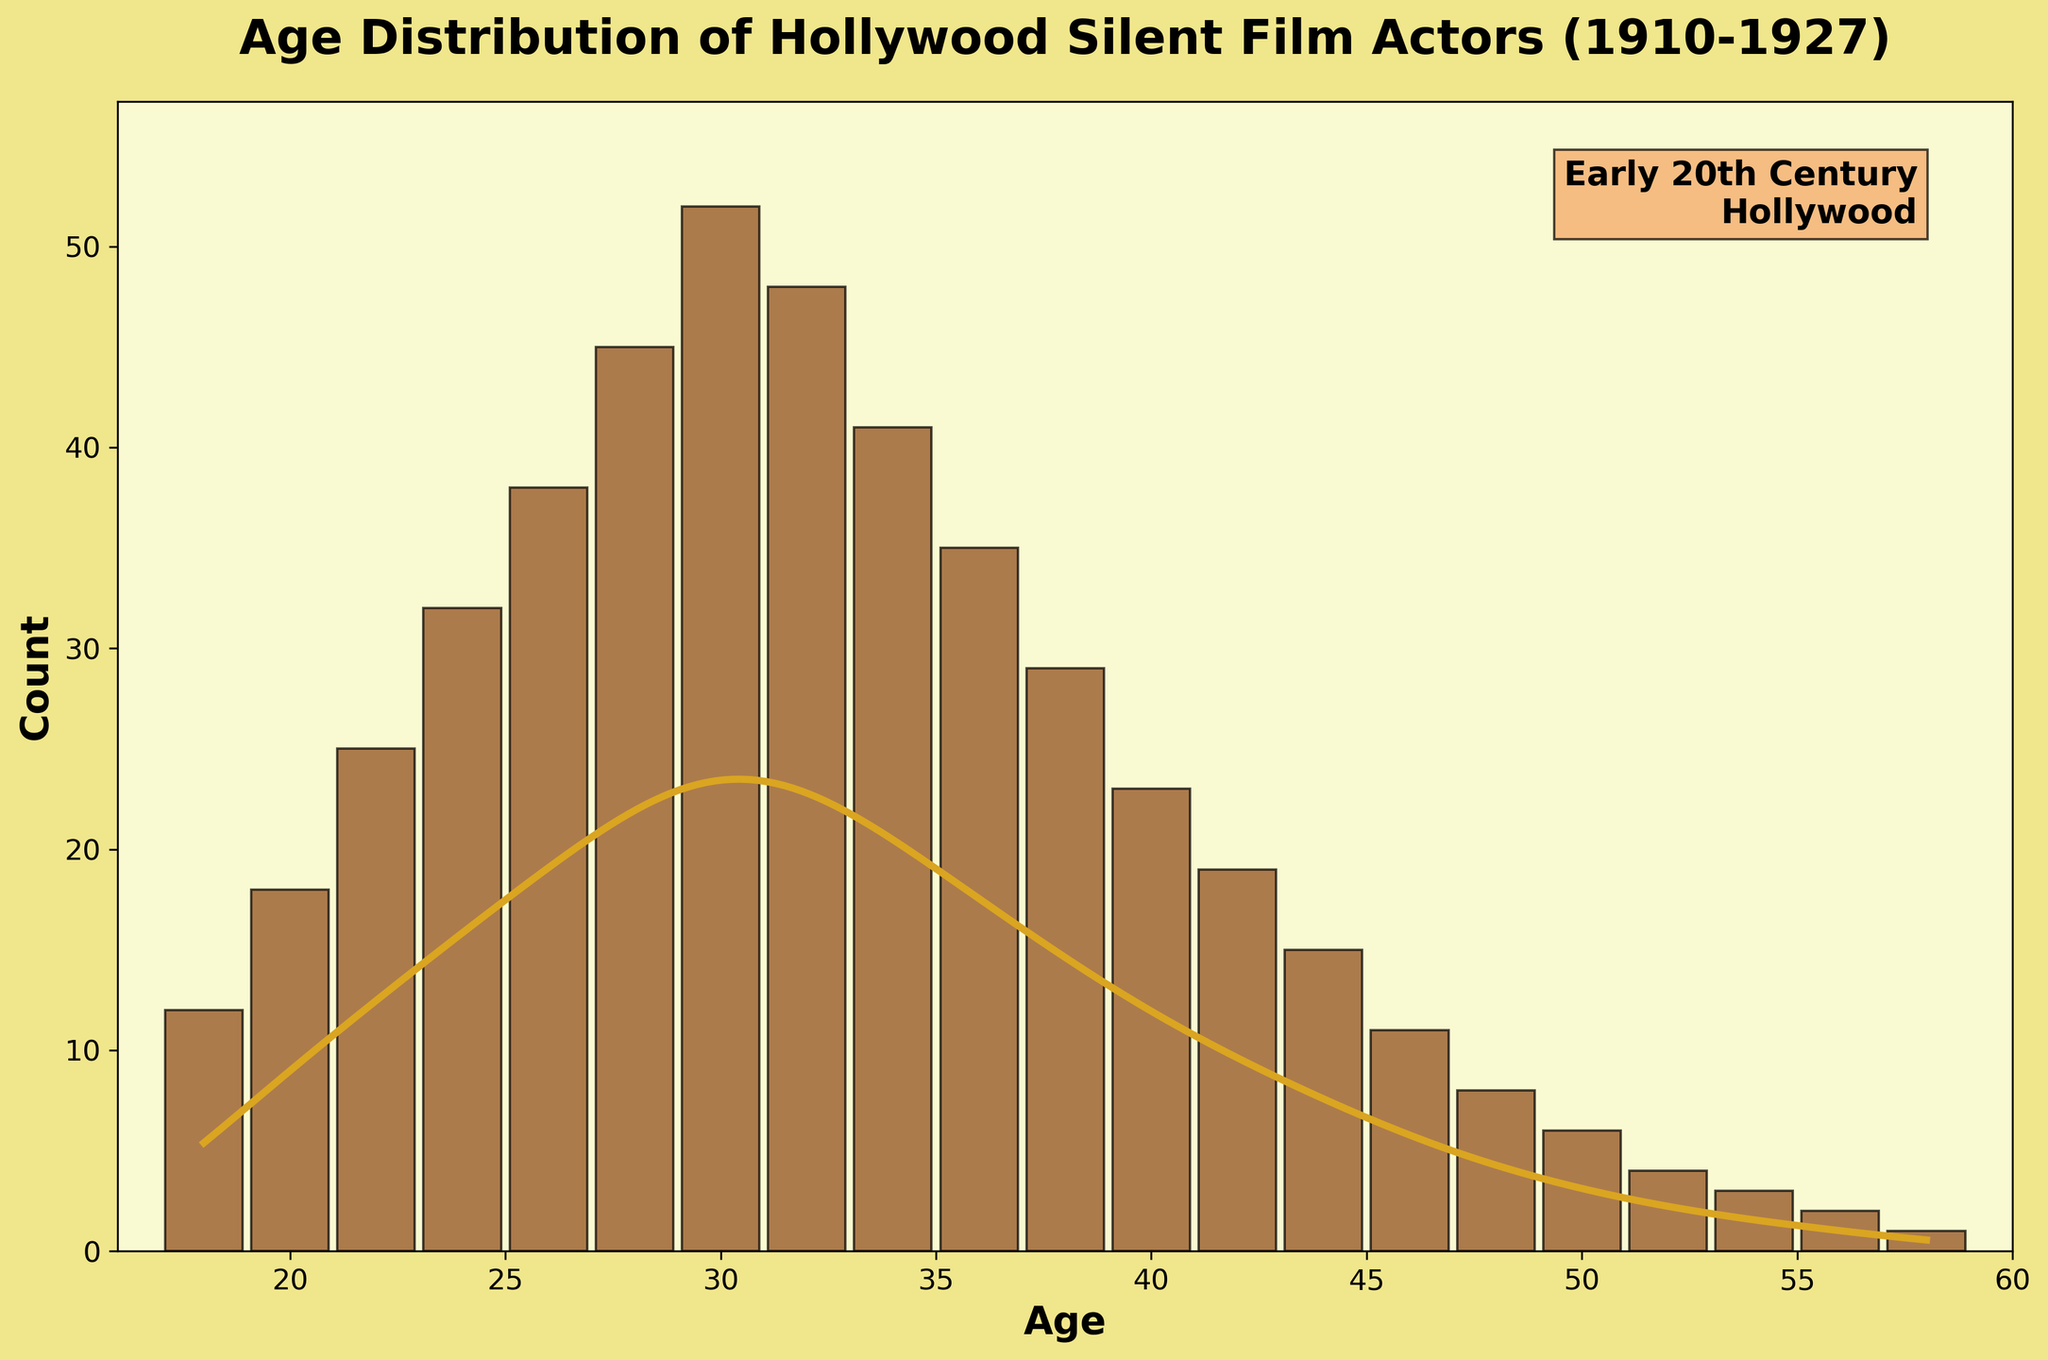What is the title of the figure? The title is prominently displayed at the top of the figure in bold.
Answer: Age Distribution of Hollywood Silent Film Actors (1910-1927) What are the age ranges shown on the x-axis? The x-axis has tick marks indicating ages, and it ranges from 16 to 60 years.
Answer: 16 to 60 What is the highest count of actors and actresses in a particular age group? The highest count is observed by identifying the tallest bar in the histogram.
Answer: 52 At which age do we observe the most actors and actresses? The age with the most actors and actresses corresponds to the tallest bar in the histogram.
Answer: 30 How does the number of actors aged 30 compare to those aged 40? Compare the heights of the bars for ages 30 and 40. The bar for age 30 is higher.
Answer: Age 30 has more actors and actresses What is the trend in the count of actors and actresses as age increases from 18 to 30? Observe the histogram bars from age 18 to 30. The bars generally increase in height, peaking at age 30.
Answer: Increasing How does the count of actors and actresses aged 24 differ from those aged 42? Compare the heights of the bars for ages 24 and 42. The bar for age 24 is higher.
Answer: Age 24 has more actors and actresses What is the pattern of the density curve (KDE) from age 18 to age 50? Follow the KDE line visually from age 18 to 50. It generally rises until reaching a peak and then starts to fall.
Answer: Rises to a peak and then falls What ages correspond to the peak of the density curve (KDE)? The peak of the KDE is found by identifying the highest point on the curve.
Answer: Around 30 to 32 How does the count of actors and actresses aged 20 differ from those aged 50? Compare the histogram bars for ages 20 and 50. The bar for age 20 is significantly higher.
Answer: Age 20 has more actors and actresses 